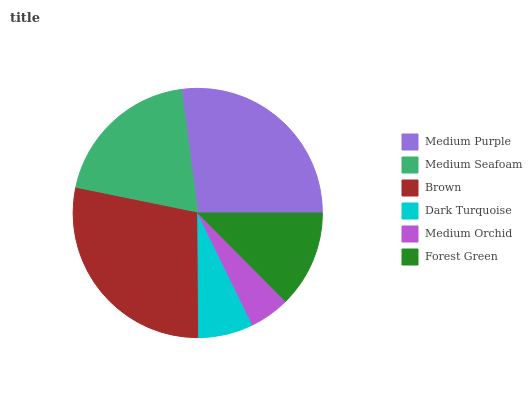Is Medium Orchid the minimum?
Answer yes or no. Yes. Is Brown the maximum?
Answer yes or no. Yes. Is Medium Seafoam the minimum?
Answer yes or no. No. Is Medium Seafoam the maximum?
Answer yes or no. No. Is Medium Purple greater than Medium Seafoam?
Answer yes or no. Yes. Is Medium Seafoam less than Medium Purple?
Answer yes or no. Yes. Is Medium Seafoam greater than Medium Purple?
Answer yes or no. No. Is Medium Purple less than Medium Seafoam?
Answer yes or no. No. Is Medium Seafoam the high median?
Answer yes or no. Yes. Is Forest Green the low median?
Answer yes or no. Yes. Is Medium Orchid the high median?
Answer yes or no. No. Is Dark Turquoise the low median?
Answer yes or no. No. 